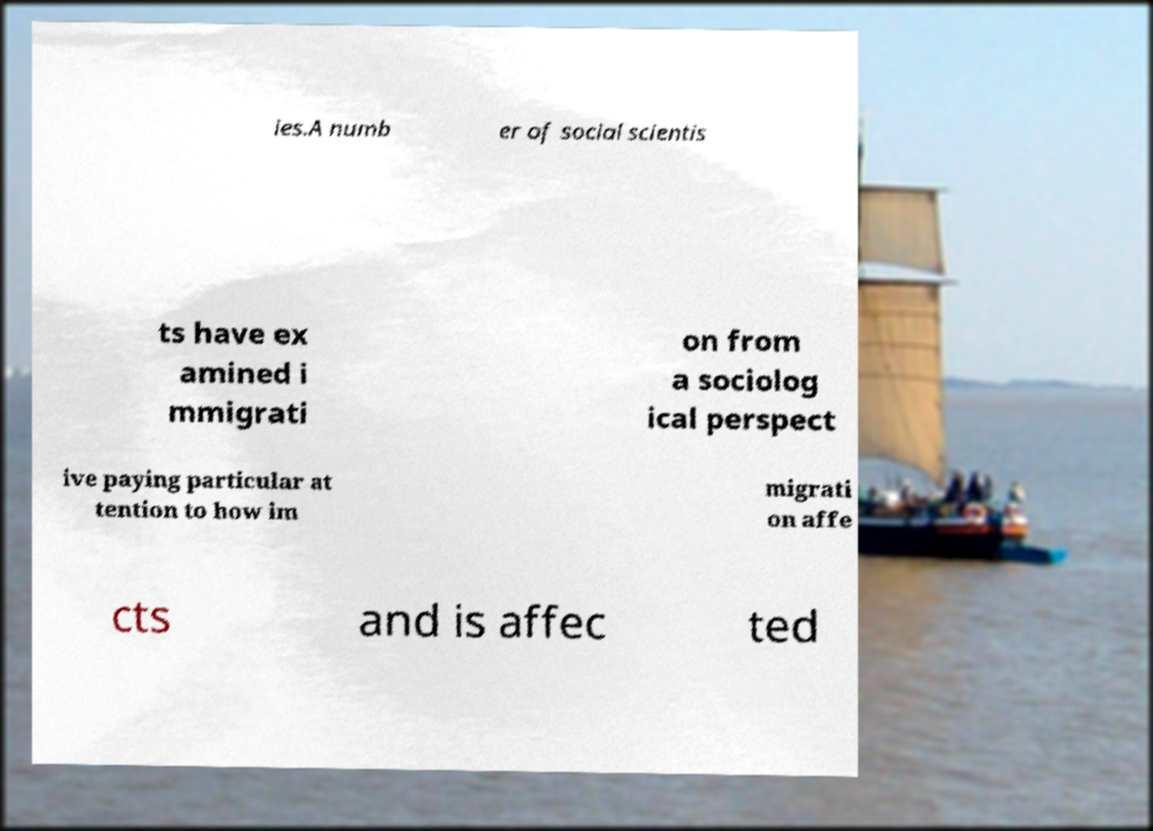Can you accurately transcribe the text from the provided image for me? ies.A numb er of social scientis ts have ex amined i mmigrati on from a sociolog ical perspect ive paying particular at tention to how im migrati on affe cts and is affec ted 